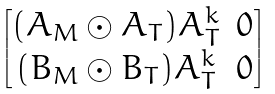Convert formula to latex. <formula><loc_0><loc_0><loc_500><loc_500>\begin{bmatrix} ( A _ { M } \odot A _ { T } ) A _ { T } ^ { k } & 0 \\ ( B _ { M } \odot B _ { T } ) A _ { T } ^ { k } & 0 \end{bmatrix}</formula> 